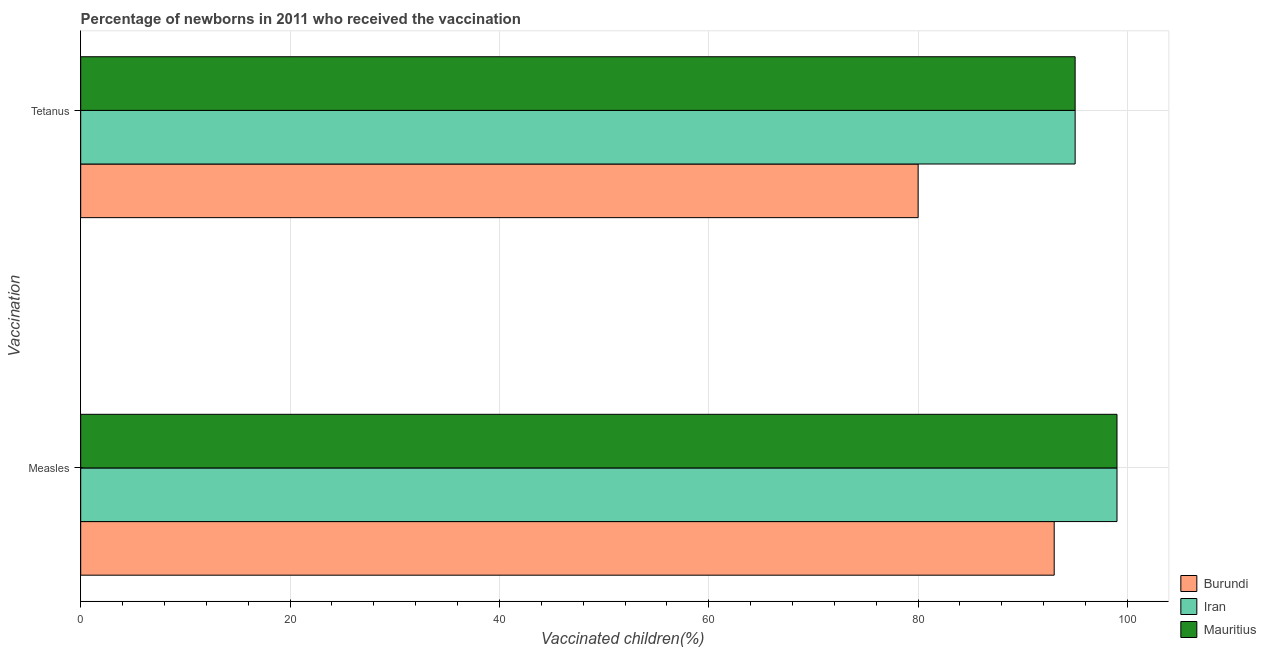How many different coloured bars are there?
Your answer should be very brief. 3. Are the number of bars on each tick of the Y-axis equal?
Provide a short and direct response. Yes. How many bars are there on the 2nd tick from the bottom?
Ensure brevity in your answer.  3. What is the label of the 2nd group of bars from the top?
Give a very brief answer. Measles. What is the percentage of newborns who received vaccination for measles in Burundi?
Offer a terse response. 93. Across all countries, what is the maximum percentage of newborns who received vaccination for measles?
Offer a very short reply. 99. Across all countries, what is the minimum percentage of newborns who received vaccination for tetanus?
Keep it short and to the point. 80. In which country was the percentage of newborns who received vaccination for measles maximum?
Provide a short and direct response. Iran. In which country was the percentage of newborns who received vaccination for measles minimum?
Provide a succinct answer. Burundi. What is the total percentage of newborns who received vaccination for measles in the graph?
Make the answer very short. 291. What is the difference between the percentage of newborns who received vaccination for tetanus in Burundi and the percentage of newborns who received vaccination for measles in Iran?
Provide a short and direct response. -19. What is the average percentage of newborns who received vaccination for measles per country?
Ensure brevity in your answer.  97. What is the difference between the percentage of newborns who received vaccination for measles and percentage of newborns who received vaccination for tetanus in Mauritius?
Your response must be concise. 4. What is the ratio of the percentage of newborns who received vaccination for tetanus in Burundi to that in Mauritius?
Provide a succinct answer. 0.84. Is the percentage of newborns who received vaccination for measles in Iran less than that in Burundi?
Make the answer very short. No. What does the 3rd bar from the top in Measles represents?
Make the answer very short. Burundi. What does the 3rd bar from the bottom in Tetanus represents?
Keep it short and to the point. Mauritius. Are all the bars in the graph horizontal?
Ensure brevity in your answer.  Yes. How many countries are there in the graph?
Offer a very short reply. 3. What is the difference between two consecutive major ticks on the X-axis?
Your answer should be very brief. 20. Does the graph contain any zero values?
Your answer should be very brief. No. Does the graph contain grids?
Your response must be concise. Yes. What is the title of the graph?
Make the answer very short. Percentage of newborns in 2011 who received the vaccination. Does "Poland" appear as one of the legend labels in the graph?
Your answer should be compact. No. What is the label or title of the X-axis?
Provide a short and direct response. Vaccinated children(%)
. What is the label or title of the Y-axis?
Provide a succinct answer. Vaccination. What is the Vaccinated children(%)
 of Burundi in Measles?
Your answer should be compact. 93. What is the Vaccinated children(%)
 of Iran in Tetanus?
Offer a terse response. 95. What is the Vaccinated children(%)
 in Mauritius in Tetanus?
Your answer should be compact. 95. Across all Vaccination, what is the maximum Vaccinated children(%)
 of Burundi?
Your answer should be compact. 93. Across all Vaccination, what is the minimum Vaccinated children(%)
 in Burundi?
Give a very brief answer. 80. Across all Vaccination, what is the minimum Vaccinated children(%)
 in Iran?
Provide a short and direct response. 95. Across all Vaccination, what is the minimum Vaccinated children(%)
 of Mauritius?
Keep it short and to the point. 95. What is the total Vaccinated children(%)
 in Burundi in the graph?
Offer a terse response. 173. What is the total Vaccinated children(%)
 in Iran in the graph?
Give a very brief answer. 194. What is the total Vaccinated children(%)
 in Mauritius in the graph?
Provide a succinct answer. 194. What is the difference between the Vaccinated children(%)
 of Iran in Measles and that in Tetanus?
Provide a succinct answer. 4. What is the difference between the Vaccinated children(%)
 in Mauritius in Measles and that in Tetanus?
Your answer should be very brief. 4. What is the difference between the Vaccinated children(%)
 of Burundi in Measles and the Vaccinated children(%)
 of Mauritius in Tetanus?
Your answer should be compact. -2. What is the average Vaccinated children(%)
 of Burundi per Vaccination?
Offer a very short reply. 86.5. What is the average Vaccinated children(%)
 of Iran per Vaccination?
Provide a succinct answer. 97. What is the average Vaccinated children(%)
 of Mauritius per Vaccination?
Offer a terse response. 97. What is the difference between the Vaccinated children(%)
 in Burundi and Vaccinated children(%)
 in Iran in Measles?
Provide a succinct answer. -6. What is the difference between the Vaccinated children(%)
 of Burundi and Vaccinated children(%)
 of Mauritius in Tetanus?
Provide a succinct answer. -15. What is the ratio of the Vaccinated children(%)
 in Burundi in Measles to that in Tetanus?
Keep it short and to the point. 1.16. What is the ratio of the Vaccinated children(%)
 of Iran in Measles to that in Tetanus?
Make the answer very short. 1.04. What is the ratio of the Vaccinated children(%)
 of Mauritius in Measles to that in Tetanus?
Give a very brief answer. 1.04. What is the difference between the highest and the second highest Vaccinated children(%)
 in Burundi?
Your answer should be very brief. 13. What is the difference between the highest and the second highest Vaccinated children(%)
 in Mauritius?
Offer a terse response. 4. What is the difference between the highest and the lowest Vaccinated children(%)
 of Iran?
Keep it short and to the point. 4. What is the difference between the highest and the lowest Vaccinated children(%)
 of Mauritius?
Offer a terse response. 4. 